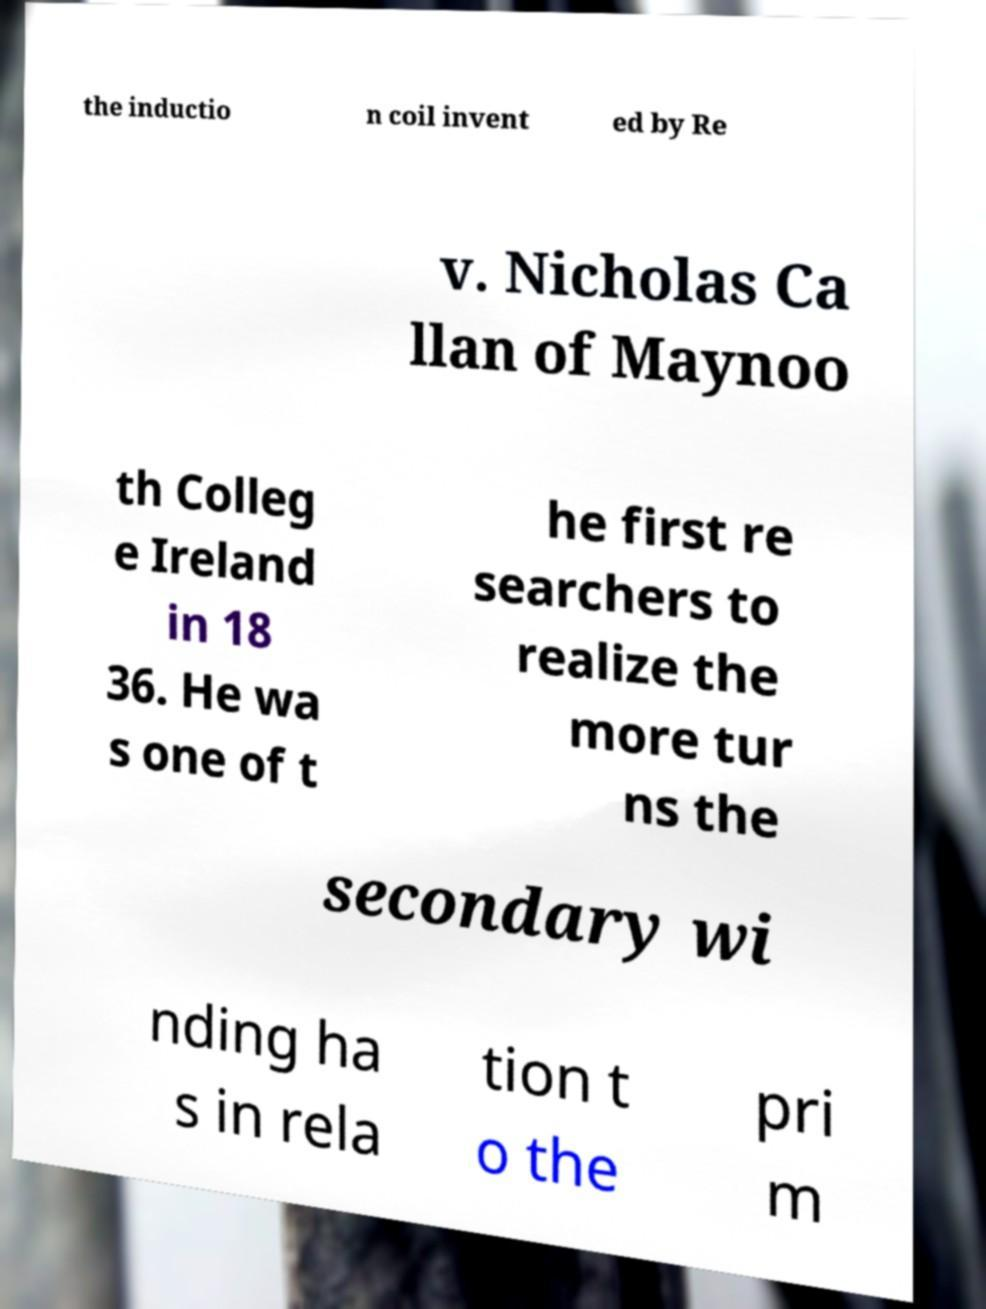Can you accurately transcribe the text from the provided image for me? the inductio n coil invent ed by Re v. Nicholas Ca llan of Maynoo th Colleg e Ireland in 18 36. He wa s one of t he first re searchers to realize the more tur ns the secondary wi nding ha s in rela tion t o the pri m 